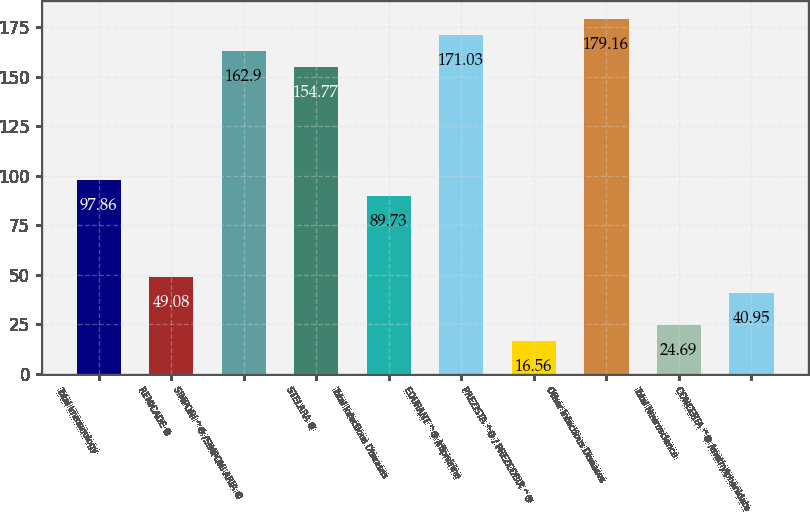Convert chart to OTSL. <chart><loc_0><loc_0><loc_500><loc_500><bar_chart><fcel>Total Immunology<fcel>REMICADE ®<fcel>SIMPONI ^® /SIMPONI ARIA ®<fcel>STELARA ®<fcel>Total Infectious Diseases<fcel>EDURANT ^® /rilpivirine<fcel>PREZISTA ^® / PREZCOBIX ^®<fcel>Other Infectious Diseases<fcel>Total Neuroscience<fcel>CONCERTA ^® /methylphenidate<nl><fcel>97.86<fcel>49.08<fcel>162.9<fcel>154.77<fcel>89.73<fcel>171.03<fcel>16.56<fcel>179.16<fcel>24.69<fcel>40.95<nl></chart> 